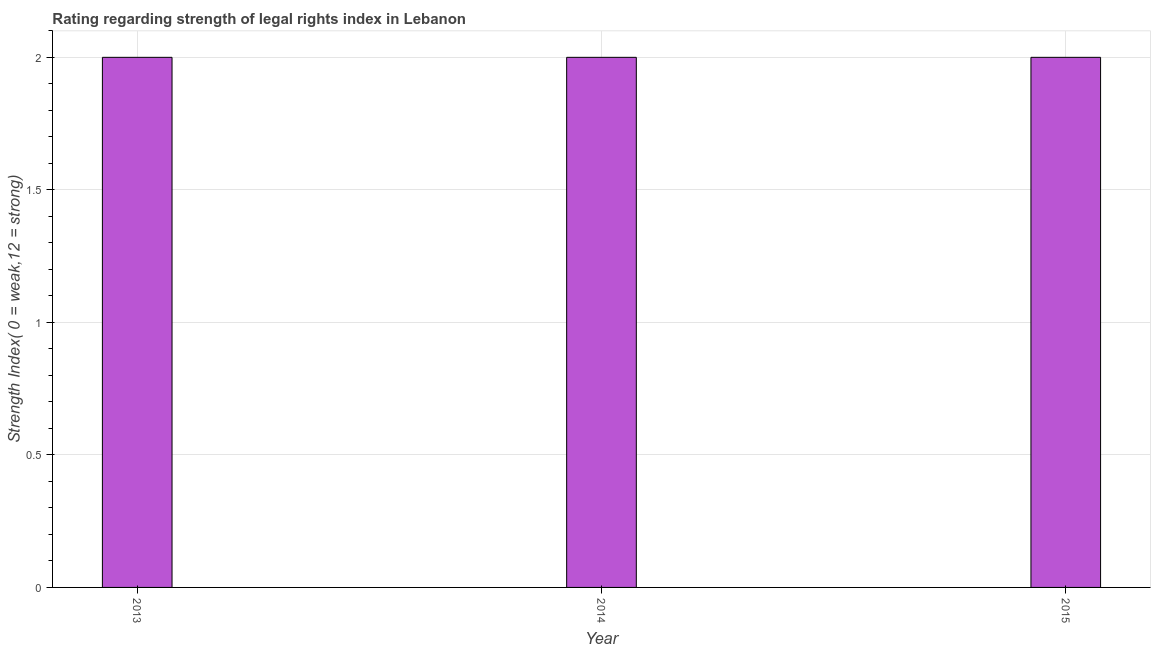Does the graph contain any zero values?
Make the answer very short. No. What is the title of the graph?
Your response must be concise. Rating regarding strength of legal rights index in Lebanon. What is the label or title of the X-axis?
Ensure brevity in your answer.  Year. What is the label or title of the Y-axis?
Offer a very short reply. Strength Index( 0 = weak,12 = strong). Across all years, what is the maximum strength of legal rights index?
Offer a very short reply. 2. Across all years, what is the minimum strength of legal rights index?
Make the answer very short. 2. In which year was the strength of legal rights index maximum?
Your answer should be very brief. 2013. In which year was the strength of legal rights index minimum?
Offer a very short reply. 2013. What is the sum of the strength of legal rights index?
Provide a succinct answer. 6. What is the difference between the strength of legal rights index in 2013 and 2014?
Ensure brevity in your answer.  0. What is the median strength of legal rights index?
Keep it short and to the point. 2. Do a majority of the years between 2015 and 2013 (inclusive) have strength of legal rights index greater than 1.2 ?
Provide a short and direct response. Yes. What is the ratio of the strength of legal rights index in 2013 to that in 2014?
Ensure brevity in your answer.  1. Is the strength of legal rights index in 2013 less than that in 2014?
Offer a terse response. No. Is the difference between the strength of legal rights index in 2014 and 2015 greater than the difference between any two years?
Offer a terse response. Yes. Is the sum of the strength of legal rights index in 2014 and 2015 greater than the maximum strength of legal rights index across all years?
Give a very brief answer. Yes. What is the difference between the highest and the lowest strength of legal rights index?
Ensure brevity in your answer.  0. In how many years, is the strength of legal rights index greater than the average strength of legal rights index taken over all years?
Give a very brief answer. 0. Are all the bars in the graph horizontal?
Make the answer very short. No. How many years are there in the graph?
Ensure brevity in your answer.  3. What is the difference between two consecutive major ticks on the Y-axis?
Give a very brief answer. 0.5. What is the Strength Index( 0 = weak,12 = strong) of 2013?
Provide a succinct answer. 2. What is the difference between the Strength Index( 0 = weak,12 = strong) in 2013 and 2014?
Your answer should be compact. 0. What is the difference between the Strength Index( 0 = weak,12 = strong) in 2014 and 2015?
Provide a short and direct response. 0. What is the ratio of the Strength Index( 0 = weak,12 = strong) in 2014 to that in 2015?
Provide a short and direct response. 1. 